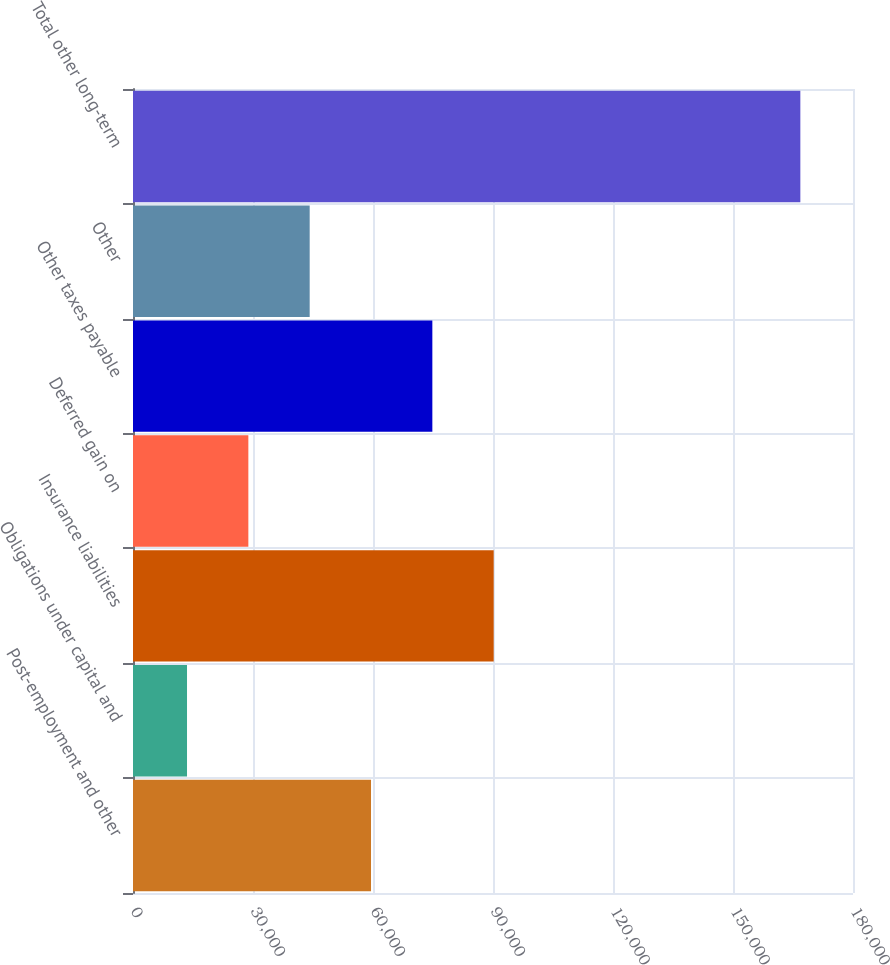Convert chart. <chart><loc_0><loc_0><loc_500><loc_500><bar_chart><fcel>Post-employment and other<fcel>Obligations under capital and<fcel>Insurance liabilities<fcel>Deferred gain on<fcel>Other taxes payable<fcel>Other<fcel>Total other long-term<nl><fcel>59503.6<fcel>13504<fcel>90170<fcel>28837.2<fcel>74836.8<fcel>44170.4<fcel>166836<nl></chart> 